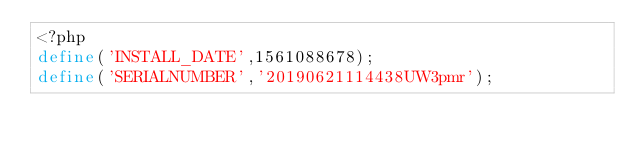Convert code to text. <code><loc_0><loc_0><loc_500><loc_500><_PHP_><?php
define('INSTALL_DATE',1561088678);
define('SERIALNUMBER','20190621114438UW3pmr');</code> 